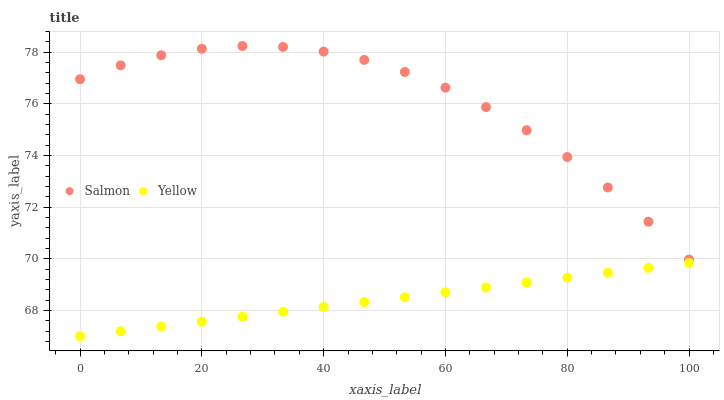Does Yellow have the minimum area under the curve?
Answer yes or no. Yes. Does Salmon have the maximum area under the curve?
Answer yes or no. Yes. Does Yellow have the maximum area under the curve?
Answer yes or no. No. Is Yellow the smoothest?
Answer yes or no. Yes. Is Salmon the roughest?
Answer yes or no. Yes. Is Yellow the roughest?
Answer yes or no. No. Does Yellow have the lowest value?
Answer yes or no. Yes. Does Salmon have the highest value?
Answer yes or no. Yes. Does Yellow have the highest value?
Answer yes or no. No. Is Yellow less than Salmon?
Answer yes or no. Yes. Is Salmon greater than Yellow?
Answer yes or no. Yes. Does Yellow intersect Salmon?
Answer yes or no. No. 